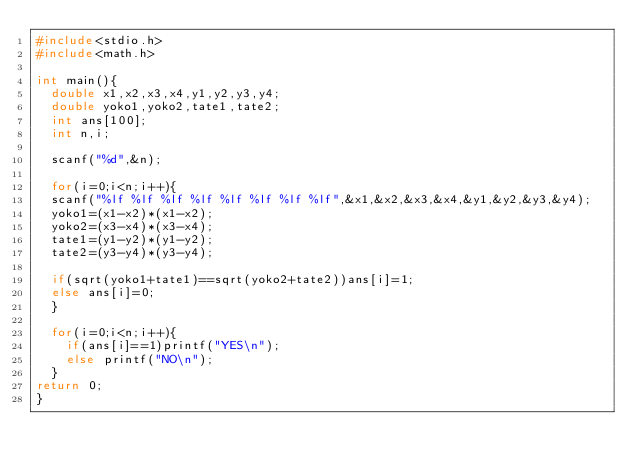<code> <loc_0><loc_0><loc_500><loc_500><_C++_>#include<stdio.h>
#include<math.h>

int main(){
	double x1,x2,x3,x4,y1,y2,y3,y4;
	double yoko1,yoko2,tate1,tate2;
	int ans[100];
	int n,i;
	
	scanf("%d",&n);
	
	for(i=0;i<n;i++){
	scanf("%lf %lf %lf %lf %lf %lf %lf %lf",&x1,&x2,&x3,&x4,&y1,&y2,&y3,&y4);
	yoko1=(x1-x2)*(x1-x2);
	yoko2=(x3-x4)*(x3-x4);
	tate1=(y1-y2)*(y1-y2);
	tate2=(y3-y4)*(y3-y4);
	
	if(sqrt(yoko1+tate1)==sqrt(yoko2+tate2))ans[i]=1;
	else ans[i]=0;
	}
	
	for(i=0;i<n;i++){
		if(ans[i]==1)printf("YES\n");
		else printf("NO\n");
	}
return 0;
}</code> 